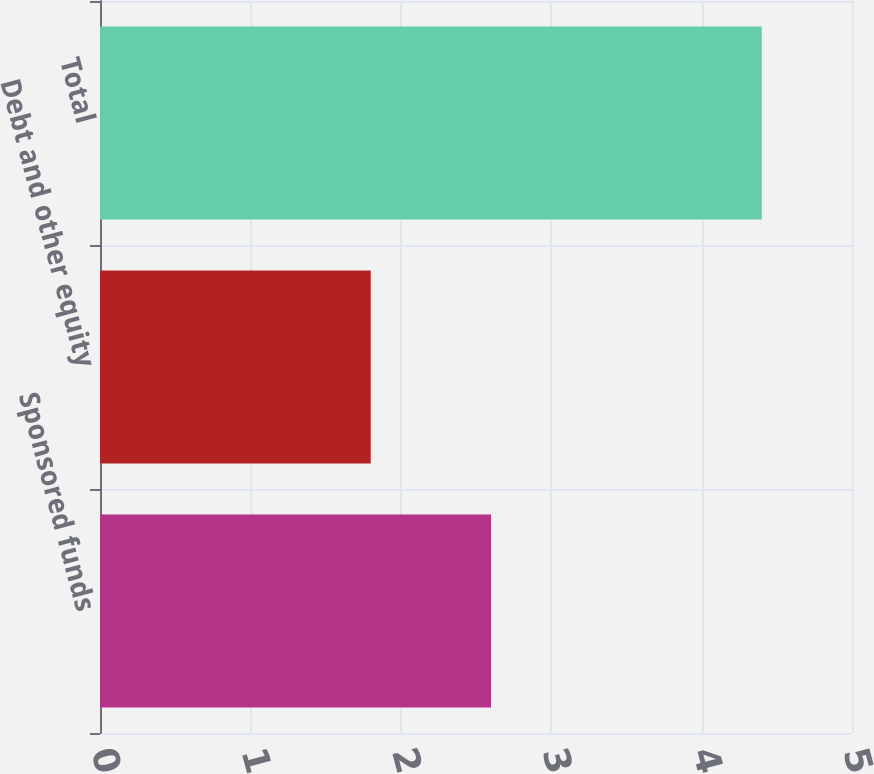Convert chart. <chart><loc_0><loc_0><loc_500><loc_500><bar_chart><fcel>Sponsored funds<fcel>Debt and other equity<fcel>Total<nl><fcel>2.6<fcel>1.8<fcel>4.4<nl></chart> 